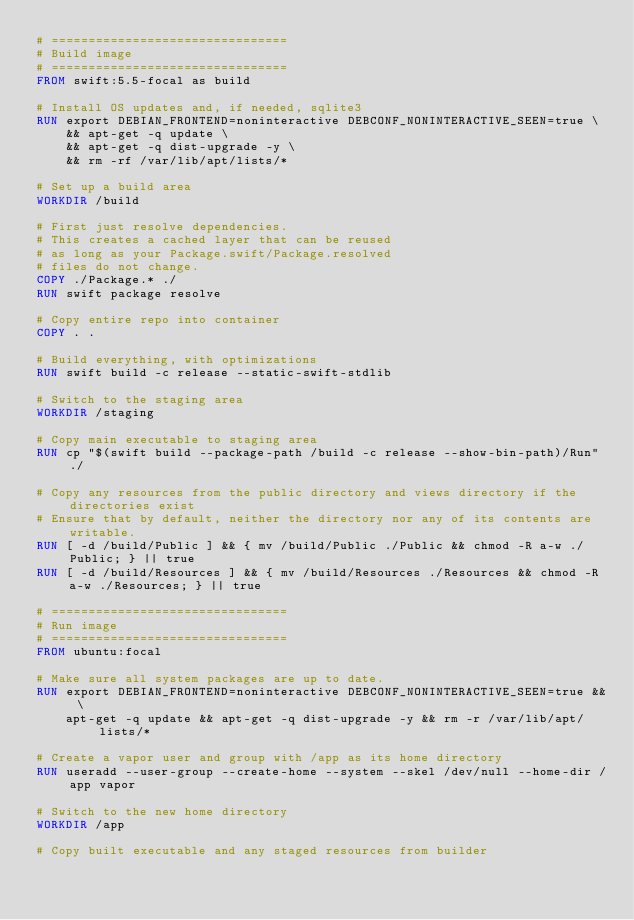<code> <loc_0><loc_0><loc_500><loc_500><_Dockerfile_># ================================
# Build image
# ================================
FROM swift:5.5-focal as build

# Install OS updates and, if needed, sqlite3
RUN export DEBIAN_FRONTEND=noninteractive DEBCONF_NONINTERACTIVE_SEEN=true \
    && apt-get -q update \
    && apt-get -q dist-upgrade -y \
    && rm -rf /var/lib/apt/lists/*

# Set up a build area
WORKDIR /build

# First just resolve dependencies.
# This creates a cached layer that can be reused
# as long as your Package.swift/Package.resolved
# files do not change.
COPY ./Package.* ./
RUN swift package resolve

# Copy entire repo into container
COPY . .

# Build everything, with optimizations
RUN swift build -c release --static-swift-stdlib

# Switch to the staging area
WORKDIR /staging

# Copy main executable to staging area
RUN cp "$(swift build --package-path /build -c release --show-bin-path)/Run" ./

# Copy any resources from the public directory and views directory if the directories exist
# Ensure that by default, neither the directory nor any of its contents are writable.
RUN [ -d /build/Public ] && { mv /build/Public ./Public && chmod -R a-w ./Public; } || true
RUN [ -d /build/Resources ] && { mv /build/Resources ./Resources && chmod -R a-w ./Resources; } || true

# ================================
# Run image
# ================================
FROM ubuntu:focal

# Make sure all system packages are up to date.
RUN export DEBIAN_FRONTEND=noninteractive DEBCONF_NONINTERACTIVE_SEEN=true && \
    apt-get -q update && apt-get -q dist-upgrade -y && rm -r /var/lib/apt/lists/*

# Create a vapor user and group with /app as its home directory
RUN useradd --user-group --create-home --system --skel /dev/null --home-dir /app vapor

# Switch to the new home directory
WORKDIR /app

# Copy built executable and any staged resources from builder</code> 